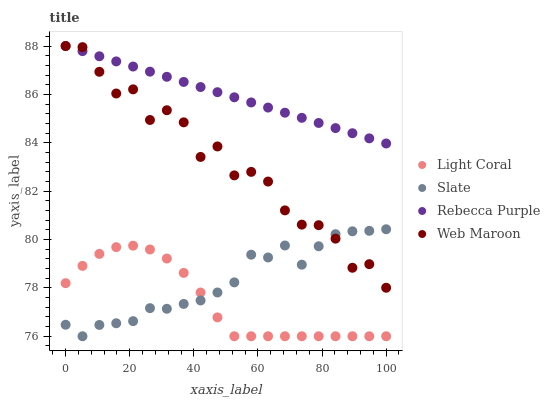Does Light Coral have the minimum area under the curve?
Answer yes or no. Yes. Does Rebecca Purple have the maximum area under the curve?
Answer yes or no. Yes. Does Slate have the minimum area under the curve?
Answer yes or no. No. Does Slate have the maximum area under the curve?
Answer yes or no. No. Is Rebecca Purple the smoothest?
Answer yes or no. Yes. Is Web Maroon the roughest?
Answer yes or no. Yes. Is Slate the smoothest?
Answer yes or no. No. Is Slate the roughest?
Answer yes or no. No. Does Light Coral have the lowest value?
Answer yes or no. Yes. Does Web Maroon have the lowest value?
Answer yes or no. No. Does Rebecca Purple have the highest value?
Answer yes or no. Yes. Does Slate have the highest value?
Answer yes or no. No. Is Light Coral less than Web Maroon?
Answer yes or no. Yes. Is Rebecca Purple greater than Light Coral?
Answer yes or no. Yes. Does Web Maroon intersect Slate?
Answer yes or no. Yes. Is Web Maroon less than Slate?
Answer yes or no. No. Is Web Maroon greater than Slate?
Answer yes or no. No. Does Light Coral intersect Web Maroon?
Answer yes or no. No. 